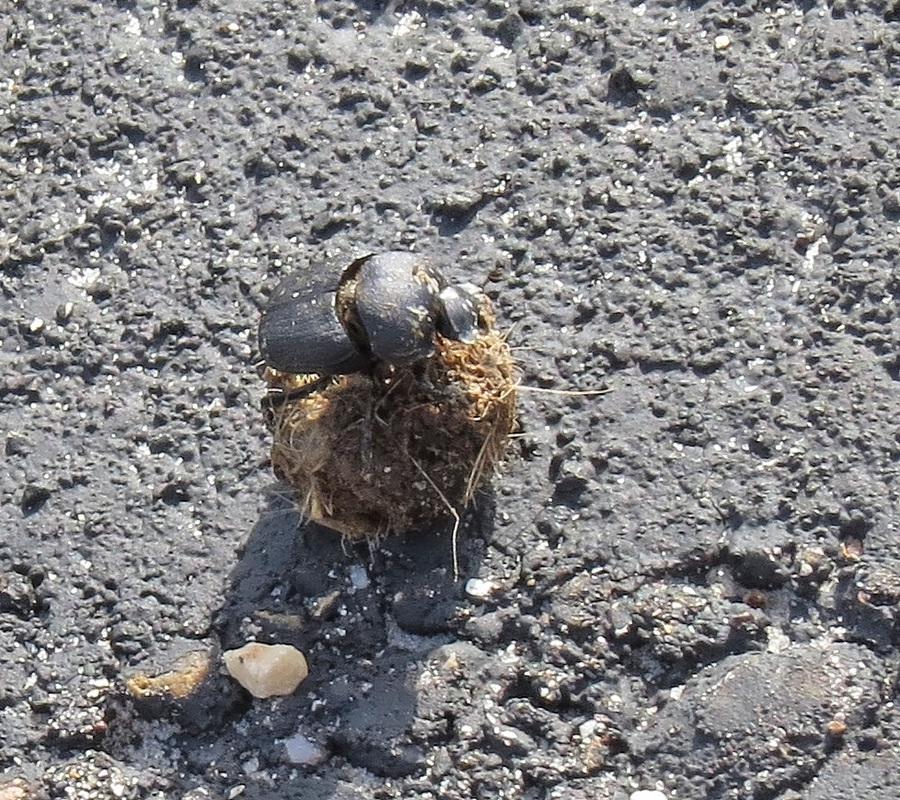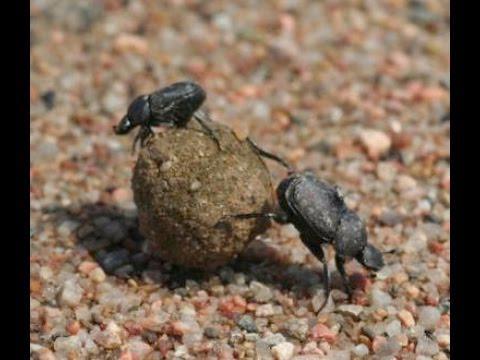The first image is the image on the left, the second image is the image on the right. For the images displayed, is the sentence "there are two dung beetles on a dung ball" factually correct? Answer yes or no. Yes. The first image is the image on the left, the second image is the image on the right. Examine the images to the left and right. Is the description "In each of the images only one dung beetle can be seen." accurate? Answer yes or no. No. 